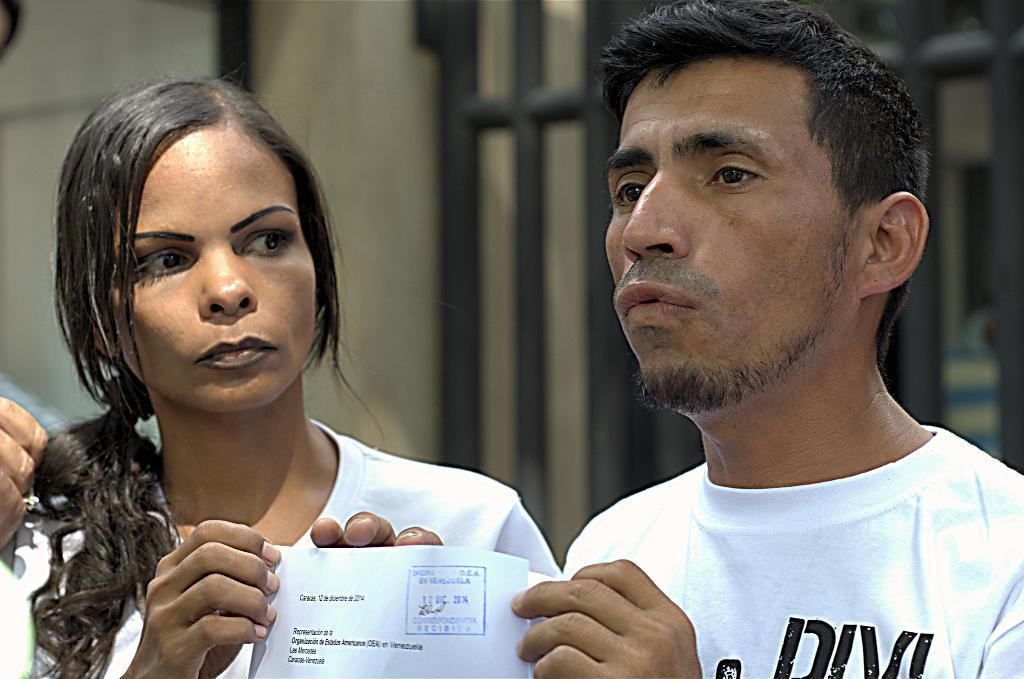How many people are in the image? There are two persons in the image. What are the persons wearing? The persons are wearing clothes. What are the persons holding in their hands? The persons are holding a paper with their hands. Can you describe the background of the image? The background of the image is blurred. What type of furniture is visible in the image? There is no furniture present in the image. What kind of connection can be seen between the two persons in the image? There is no visible connection between the two persons in the image; they are simply holding a paper. 